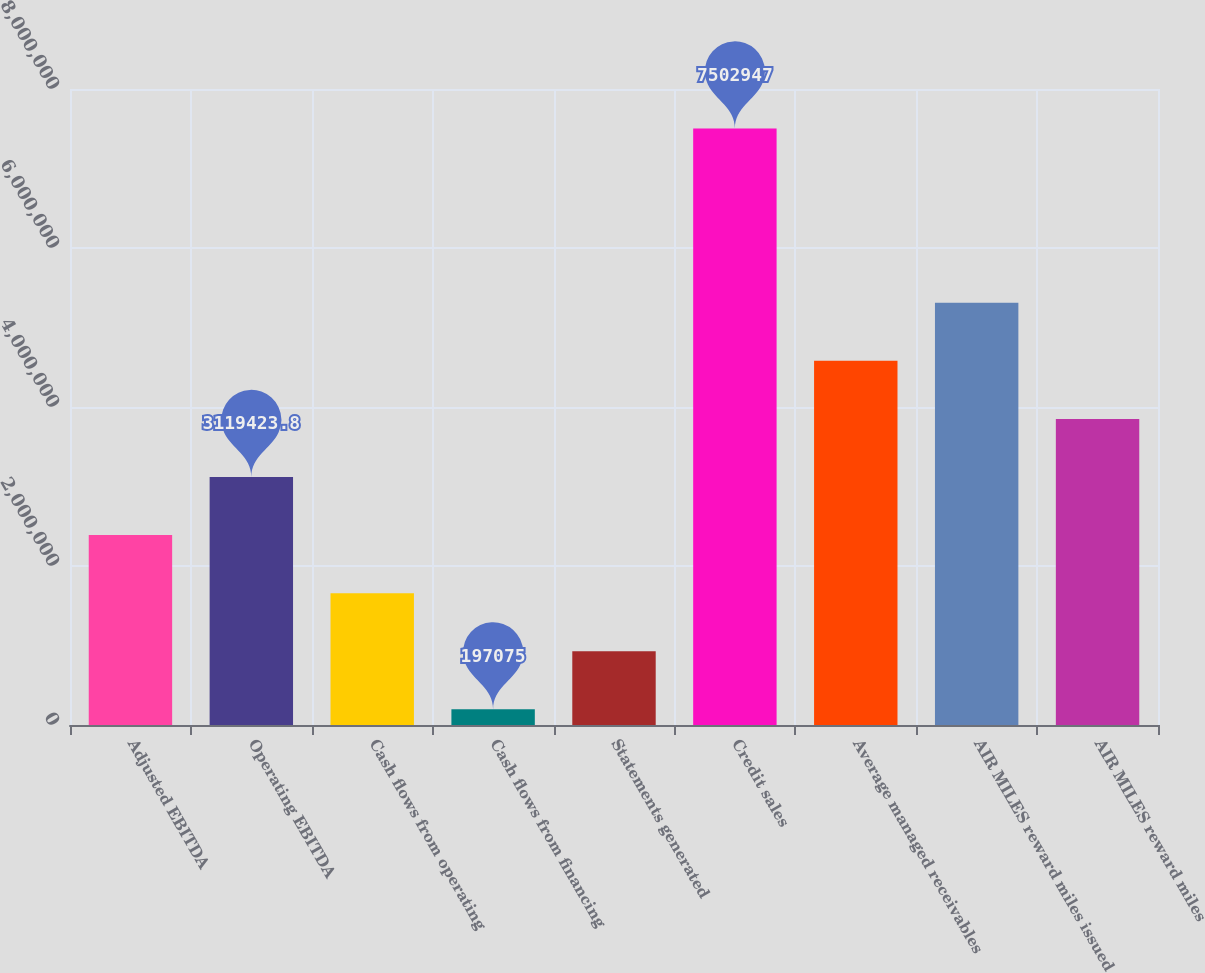Convert chart to OTSL. <chart><loc_0><loc_0><loc_500><loc_500><bar_chart><fcel>Adjusted EBITDA<fcel>Operating EBITDA<fcel>Cash flows from operating<fcel>Cash flows from financing<fcel>Statements generated<fcel>Credit sales<fcel>Average managed receivables<fcel>AIR MILES reward miles issued<fcel>AIR MILES reward miles<nl><fcel>2.38884e+06<fcel>3.11942e+06<fcel>1.65825e+06<fcel>197075<fcel>927662<fcel>7.50295e+06<fcel>4.5806e+06<fcel>5.31119e+06<fcel>3.85001e+06<nl></chart> 